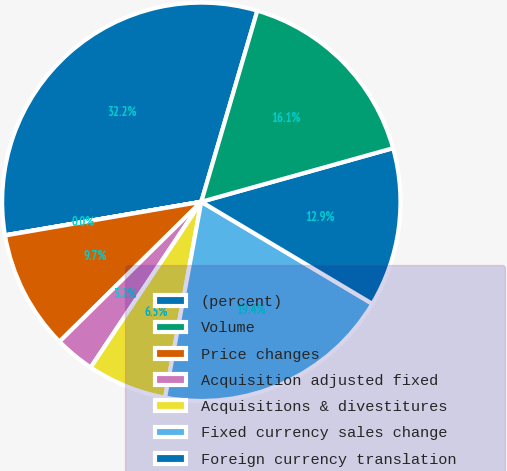Convert chart to OTSL. <chart><loc_0><loc_0><loc_500><loc_500><pie_chart><fcel>(percent)<fcel>Volume<fcel>Price changes<fcel>Acquisition adjusted fixed<fcel>Acquisitions & divestitures<fcel>Fixed currency sales change<fcel>Foreign currency translation<fcel>Reported GAAP net sales change<nl><fcel>32.23%<fcel>0.02%<fcel>9.68%<fcel>3.24%<fcel>6.46%<fcel>19.35%<fcel>12.9%<fcel>16.12%<nl></chart> 